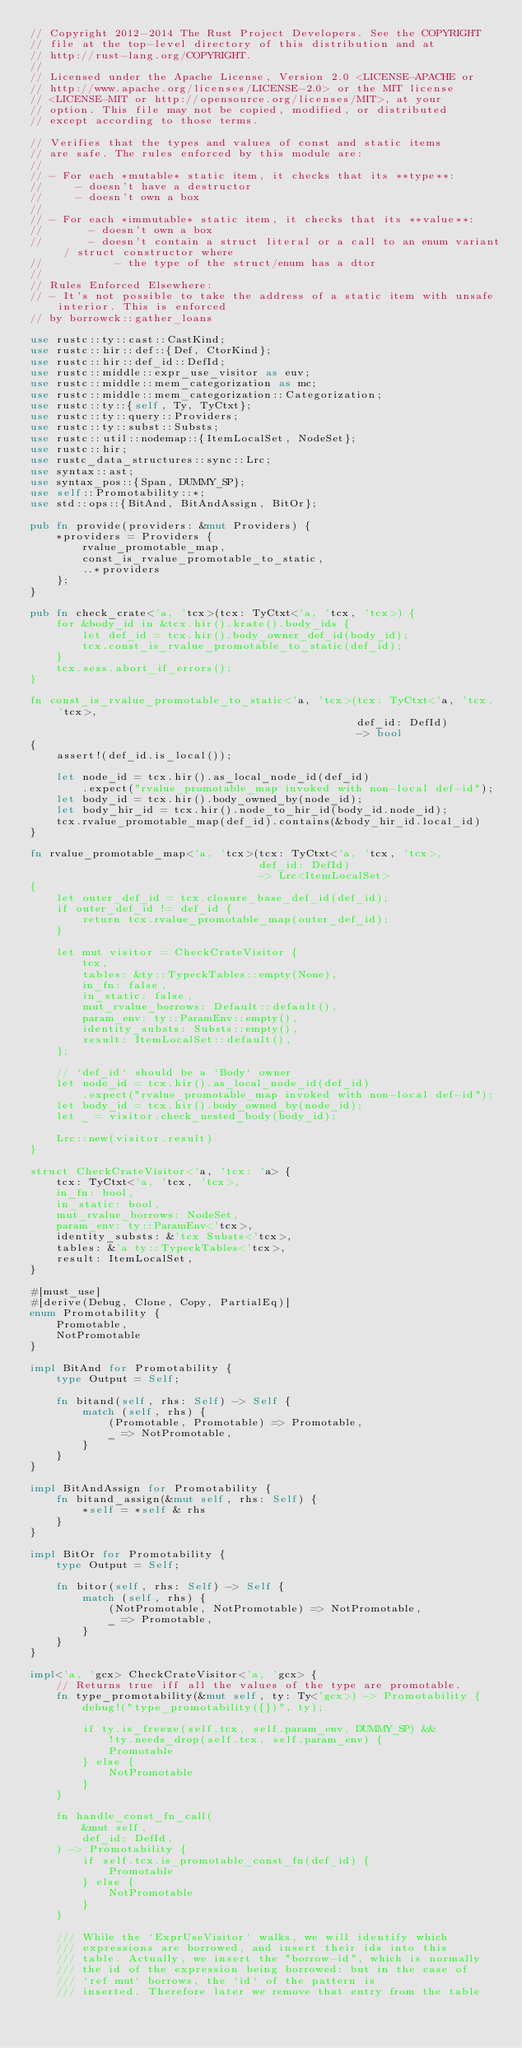<code> <loc_0><loc_0><loc_500><loc_500><_Rust_>// Copyright 2012-2014 The Rust Project Developers. See the COPYRIGHT
// file at the top-level directory of this distribution and at
// http://rust-lang.org/COPYRIGHT.
//
// Licensed under the Apache License, Version 2.0 <LICENSE-APACHE or
// http://www.apache.org/licenses/LICENSE-2.0> or the MIT license
// <LICENSE-MIT or http://opensource.org/licenses/MIT>, at your
// option. This file may not be copied, modified, or distributed
// except according to those terms.

// Verifies that the types and values of const and static items
// are safe. The rules enforced by this module are:
//
// - For each *mutable* static item, it checks that its **type**:
//     - doesn't have a destructor
//     - doesn't own a box
//
// - For each *immutable* static item, it checks that its **value**:
//       - doesn't own a box
//       - doesn't contain a struct literal or a call to an enum variant / struct constructor where
//           - the type of the struct/enum has a dtor
//
// Rules Enforced Elsewhere:
// - It's not possible to take the address of a static item with unsafe interior. This is enforced
// by borrowck::gather_loans

use rustc::ty::cast::CastKind;
use rustc::hir::def::{Def, CtorKind};
use rustc::hir::def_id::DefId;
use rustc::middle::expr_use_visitor as euv;
use rustc::middle::mem_categorization as mc;
use rustc::middle::mem_categorization::Categorization;
use rustc::ty::{self, Ty, TyCtxt};
use rustc::ty::query::Providers;
use rustc::ty::subst::Substs;
use rustc::util::nodemap::{ItemLocalSet, NodeSet};
use rustc::hir;
use rustc_data_structures::sync::Lrc;
use syntax::ast;
use syntax_pos::{Span, DUMMY_SP};
use self::Promotability::*;
use std::ops::{BitAnd, BitAndAssign, BitOr};

pub fn provide(providers: &mut Providers) {
    *providers = Providers {
        rvalue_promotable_map,
        const_is_rvalue_promotable_to_static,
        ..*providers
    };
}

pub fn check_crate<'a, 'tcx>(tcx: TyCtxt<'a, 'tcx, 'tcx>) {
    for &body_id in &tcx.hir().krate().body_ids {
        let def_id = tcx.hir().body_owner_def_id(body_id);
        tcx.const_is_rvalue_promotable_to_static(def_id);
    }
    tcx.sess.abort_if_errors();
}

fn const_is_rvalue_promotable_to_static<'a, 'tcx>(tcx: TyCtxt<'a, 'tcx, 'tcx>,
                                                  def_id: DefId)
                                                  -> bool
{
    assert!(def_id.is_local());

    let node_id = tcx.hir().as_local_node_id(def_id)
        .expect("rvalue_promotable_map invoked with non-local def-id");
    let body_id = tcx.hir().body_owned_by(node_id);
    let body_hir_id = tcx.hir().node_to_hir_id(body_id.node_id);
    tcx.rvalue_promotable_map(def_id).contains(&body_hir_id.local_id)
}

fn rvalue_promotable_map<'a, 'tcx>(tcx: TyCtxt<'a, 'tcx, 'tcx>,
                                   def_id: DefId)
                                   -> Lrc<ItemLocalSet>
{
    let outer_def_id = tcx.closure_base_def_id(def_id);
    if outer_def_id != def_id {
        return tcx.rvalue_promotable_map(outer_def_id);
    }

    let mut visitor = CheckCrateVisitor {
        tcx,
        tables: &ty::TypeckTables::empty(None),
        in_fn: false,
        in_static: false,
        mut_rvalue_borrows: Default::default(),
        param_env: ty::ParamEnv::empty(),
        identity_substs: Substs::empty(),
        result: ItemLocalSet::default(),
    };

    // `def_id` should be a `Body` owner
    let node_id = tcx.hir().as_local_node_id(def_id)
        .expect("rvalue_promotable_map invoked with non-local def-id");
    let body_id = tcx.hir().body_owned_by(node_id);
    let _ = visitor.check_nested_body(body_id);

    Lrc::new(visitor.result)
}

struct CheckCrateVisitor<'a, 'tcx: 'a> {
    tcx: TyCtxt<'a, 'tcx, 'tcx>,
    in_fn: bool,
    in_static: bool,
    mut_rvalue_borrows: NodeSet,
    param_env: ty::ParamEnv<'tcx>,
    identity_substs: &'tcx Substs<'tcx>,
    tables: &'a ty::TypeckTables<'tcx>,
    result: ItemLocalSet,
}

#[must_use]
#[derive(Debug, Clone, Copy, PartialEq)]
enum Promotability {
    Promotable,
    NotPromotable
}

impl BitAnd for Promotability {
    type Output = Self;

    fn bitand(self, rhs: Self) -> Self {
        match (self, rhs) {
            (Promotable, Promotable) => Promotable,
            _ => NotPromotable,
        }
    }
}

impl BitAndAssign for Promotability {
    fn bitand_assign(&mut self, rhs: Self) {
        *self = *self & rhs
    }
}

impl BitOr for Promotability {
    type Output = Self;

    fn bitor(self, rhs: Self) -> Self {
        match (self, rhs) {
            (NotPromotable, NotPromotable) => NotPromotable,
            _ => Promotable,
        }
    }
}

impl<'a, 'gcx> CheckCrateVisitor<'a, 'gcx> {
    // Returns true iff all the values of the type are promotable.
    fn type_promotability(&mut self, ty: Ty<'gcx>) -> Promotability {
        debug!("type_promotability({})", ty);

        if ty.is_freeze(self.tcx, self.param_env, DUMMY_SP) &&
            !ty.needs_drop(self.tcx, self.param_env) {
            Promotable
        } else {
            NotPromotable
        }
    }

    fn handle_const_fn_call(
        &mut self,
        def_id: DefId,
    ) -> Promotability {
        if self.tcx.is_promotable_const_fn(def_id) {
            Promotable
        } else {
            NotPromotable
        }
    }

    /// While the `ExprUseVisitor` walks, we will identify which
    /// expressions are borrowed, and insert their ids into this
    /// table. Actually, we insert the "borrow-id", which is normally
    /// the id of the expression being borrowed: but in the case of
    /// `ref mut` borrows, the `id` of the pattern is
    /// inserted. Therefore later we remove that entry from the table</code> 